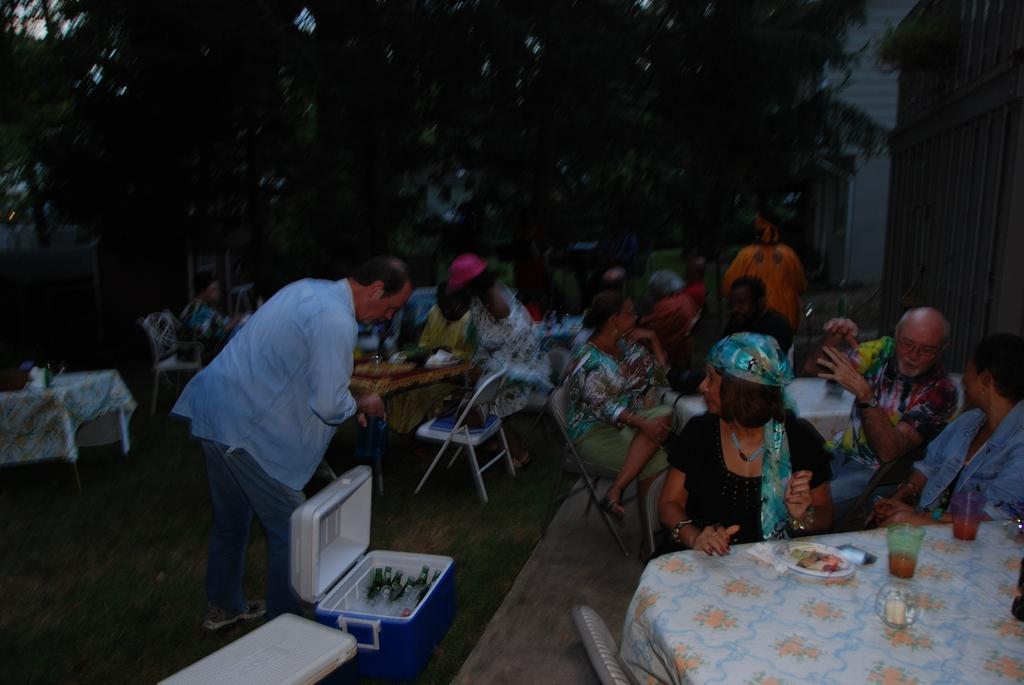Describe this image in one or two sentences. In this picture there are many people are sitting on the table and food eatables on top of it. There is a guy opening a air cooler box and inside it there are many glass bottles. In the background there are many trees and to the left side there are two houses. 